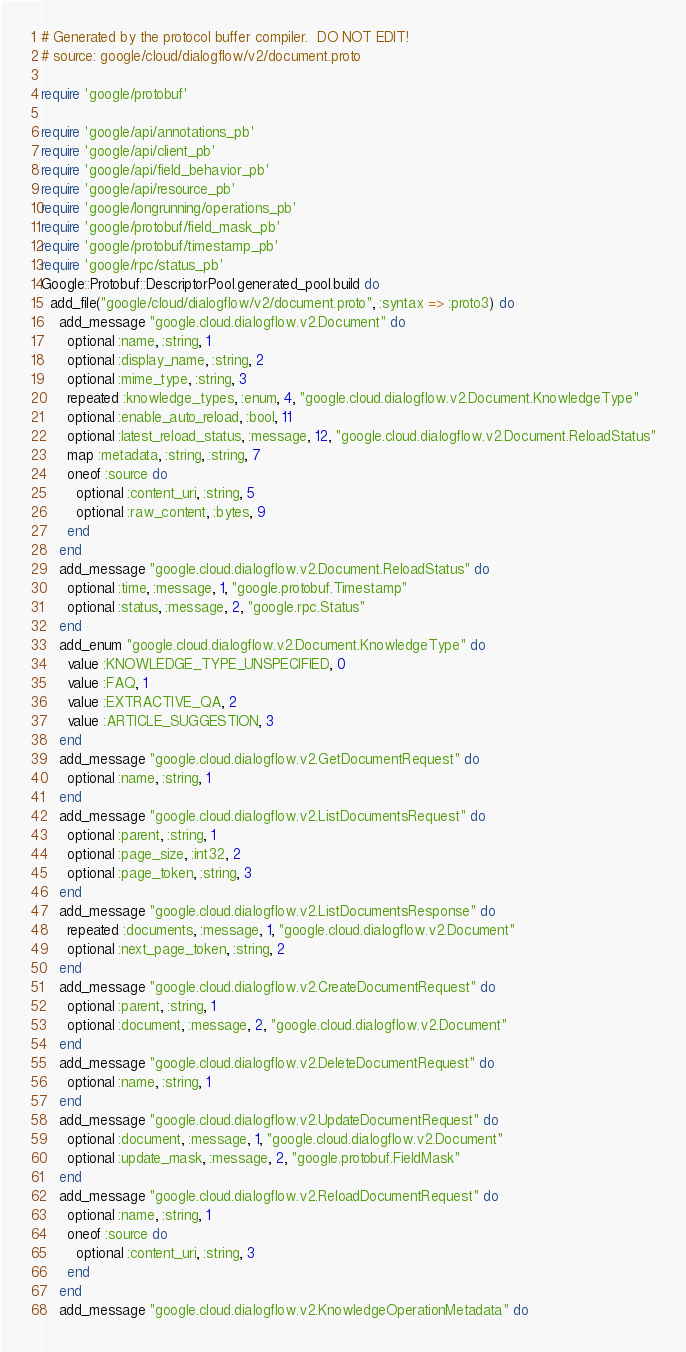<code> <loc_0><loc_0><loc_500><loc_500><_Ruby_># Generated by the protocol buffer compiler.  DO NOT EDIT!
# source: google/cloud/dialogflow/v2/document.proto

require 'google/protobuf'

require 'google/api/annotations_pb'
require 'google/api/client_pb'
require 'google/api/field_behavior_pb'
require 'google/api/resource_pb'
require 'google/longrunning/operations_pb'
require 'google/protobuf/field_mask_pb'
require 'google/protobuf/timestamp_pb'
require 'google/rpc/status_pb'
Google::Protobuf::DescriptorPool.generated_pool.build do
  add_file("google/cloud/dialogflow/v2/document.proto", :syntax => :proto3) do
    add_message "google.cloud.dialogflow.v2.Document" do
      optional :name, :string, 1
      optional :display_name, :string, 2
      optional :mime_type, :string, 3
      repeated :knowledge_types, :enum, 4, "google.cloud.dialogflow.v2.Document.KnowledgeType"
      optional :enable_auto_reload, :bool, 11
      optional :latest_reload_status, :message, 12, "google.cloud.dialogflow.v2.Document.ReloadStatus"
      map :metadata, :string, :string, 7
      oneof :source do
        optional :content_uri, :string, 5
        optional :raw_content, :bytes, 9
      end
    end
    add_message "google.cloud.dialogflow.v2.Document.ReloadStatus" do
      optional :time, :message, 1, "google.protobuf.Timestamp"
      optional :status, :message, 2, "google.rpc.Status"
    end
    add_enum "google.cloud.dialogflow.v2.Document.KnowledgeType" do
      value :KNOWLEDGE_TYPE_UNSPECIFIED, 0
      value :FAQ, 1
      value :EXTRACTIVE_QA, 2
      value :ARTICLE_SUGGESTION, 3
    end
    add_message "google.cloud.dialogflow.v2.GetDocumentRequest" do
      optional :name, :string, 1
    end
    add_message "google.cloud.dialogflow.v2.ListDocumentsRequest" do
      optional :parent, :string, 1
      optional :page_size, :int32, 2
      optional :page_token, :string, 3
    end
    add_message "google.cloud.dialogflow.v2.ListDocumentsResponse" do
      repeated :documents, :message, 1, "google.cloud.dialogflow.v2.Document"
      optional :next_page_token, :string, 2
    end
    add_message "google.cloud.dialogflow.v2.CreateDocumentRequest" do
      optional :parent, :string, 1
      optional :document, :message, 2, "google.cloud.dialogflow.v2.Document"
    end
    add_message "google.cloud.dialogflow.v2.DeleteDocumentRequest" do
      optional :name, :string, 1
    end
    add_message "google.cloud.dialogflow.v2.UpdateDocumentRequest" do
      optional :document, :message, 1, "google.cloud.dialogflow.v2.Document"
      optional :update_mask, :message, 2, "google.protobuf.FieldMask"
    end
    add_message "google.cloud.dialogflow.v2.ReloadDocumentRequest" do
      optional :name, :string, 1
      oneof :source do
        optional :content_uri, :string, 3
      end
    end
    add_message "google.cloud.dialogflow.v2.KnowledgeOperationMetadata" do</code> 